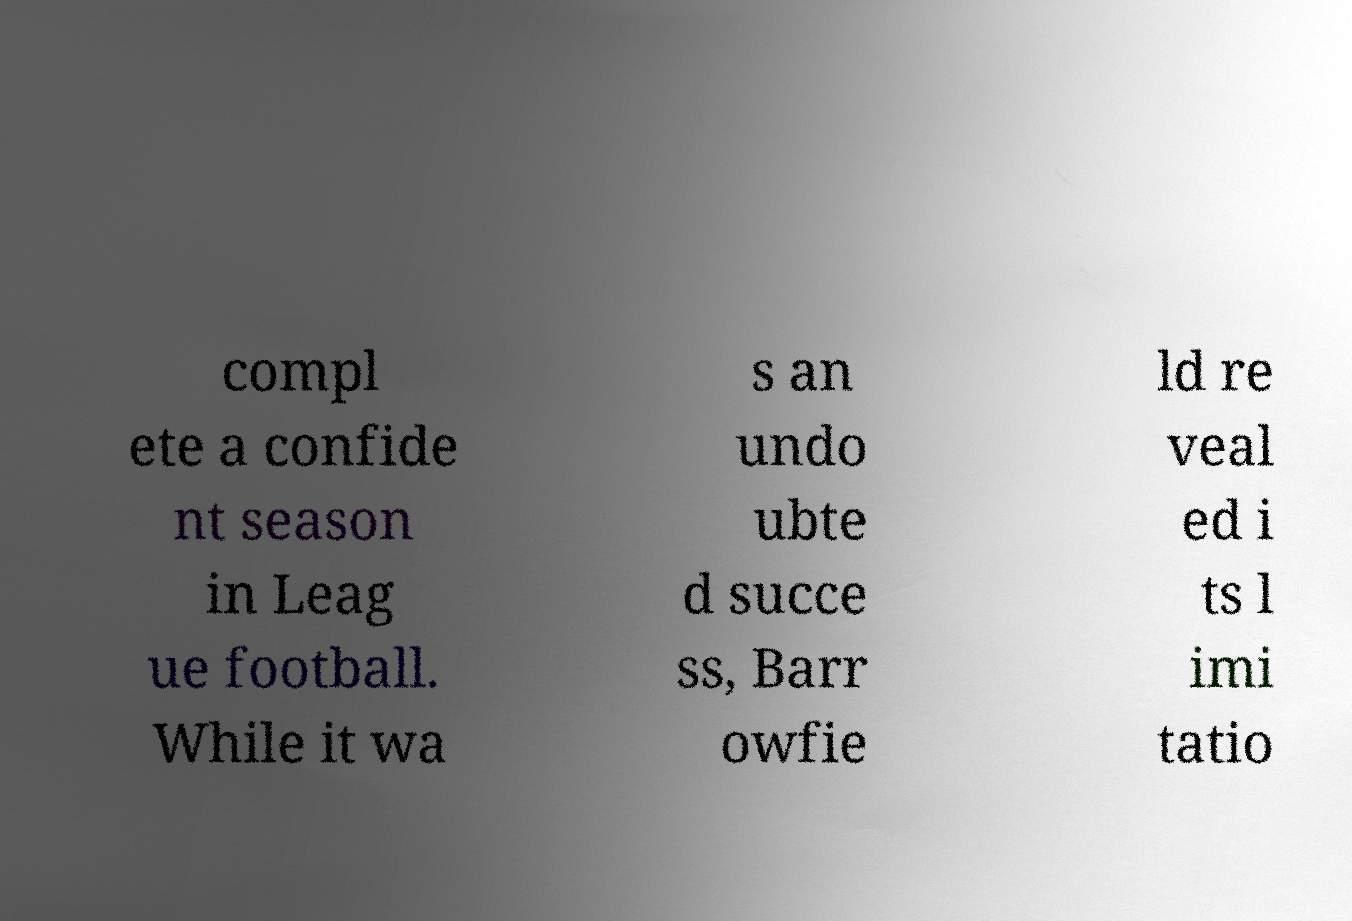Please identify and transcribe the text found in this image. compl ete a confide nt season in Leag ue football. While it wa s an undo ubte d succe ss, Barr owfie ld re veal ed i ts l imi tatio 